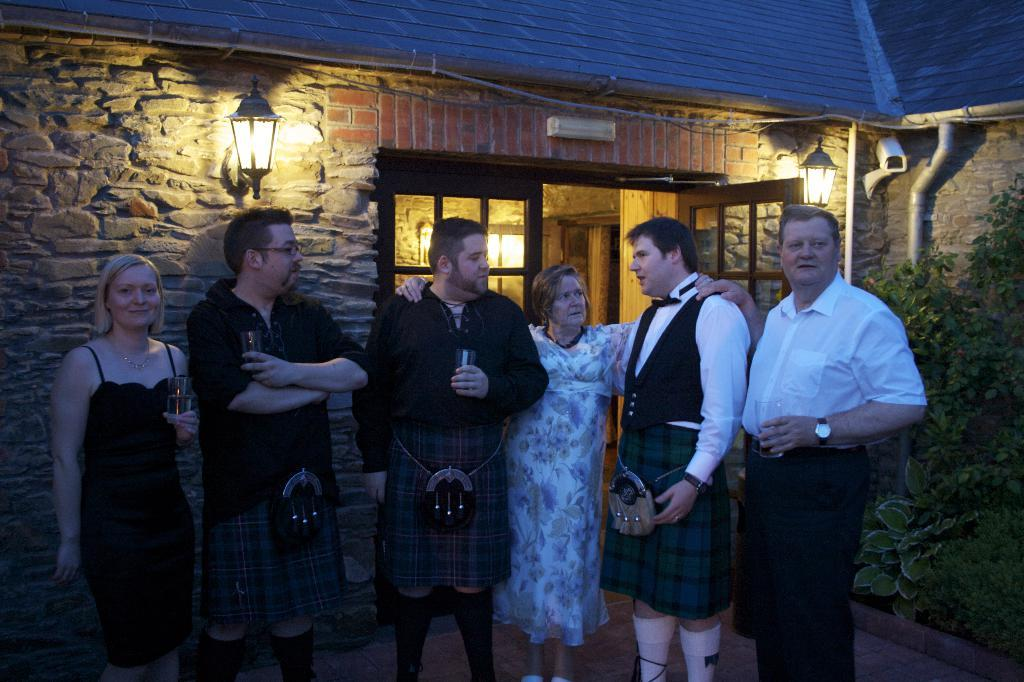What is happening in the middle of the picture? There is a group of people standing in the middle of the picture. What can be seen in the background of the image? There is a building, a door, a wall, a light, a camera, a tree, a pipe, and other objects in the background of the image. What type of rice is being served in the crate in the image? There is no rice or crate present in the image. What attraction is the group of people visiting in the image? The image does not provide information about the group's purpose or destination, so it cannot be determined if they are visiting an attraction. 